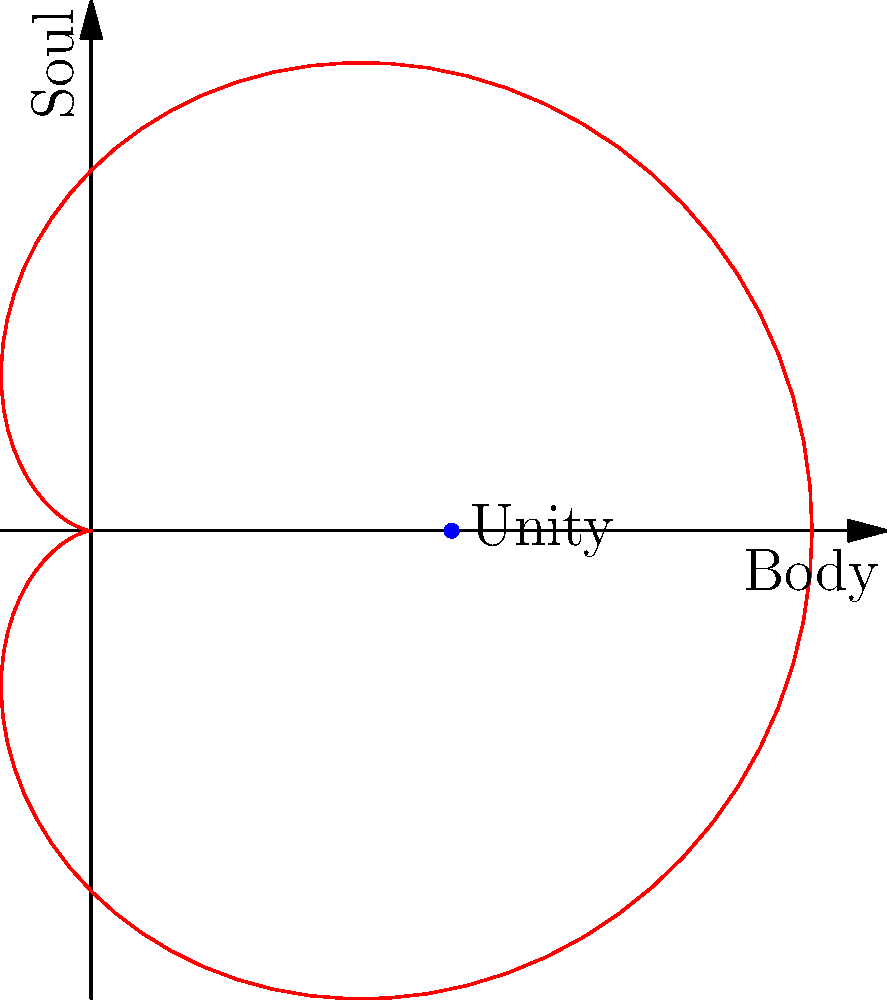In Thomistic philosophy, the unity of body and soul is often represented by the cardioid curve $r = 2(1 + \cos(\theta))$. If this curve represents the integration of body and soul, what point on the curve symbolizes the perfect unity according to Aquinas' hylomorphic theory? To answer this question, let's follow these steps:

1) The cardioid curve is given by the equation $r = 2(1 + \cos(\theta))$ in polar coordinates.

2) In Thomistic philosophy, the body and soul are not two separate entities but form a unified whole. This is represented by the continuous nature of the cardioid.

3) The perfect unity of body and soul would be represented by the point where the curve is closest to the origin, symbolizing the most intimate connection between the material (body) and immaterial (soul) aspects.

4) To find this point, we need to determine where $r$ is at its minimum:

   $\frac{dr}{d\theta} = -2\sin(\theta) = 0$

5) This occurs when $\theta = 0$ or $\pi$.

6) When $\theta = 0$, $r = 2(1 + \cos(0)) = 4$
   When $\theta = \pi$, $r = 2(1 + \cos(\pi)) = 0$

7) The point $(0,0)$ represents complete separation, which is not what we're looking for.

8) Therefore, the point of perfect unity is when $\theta = 0$ and $r = 4$.

9) In Cartesian coordinates, this point is $(4,0)$.

10) On our scaled diagram, this point is represented as $(2,0)$.
Answer: $(2,0)$ 